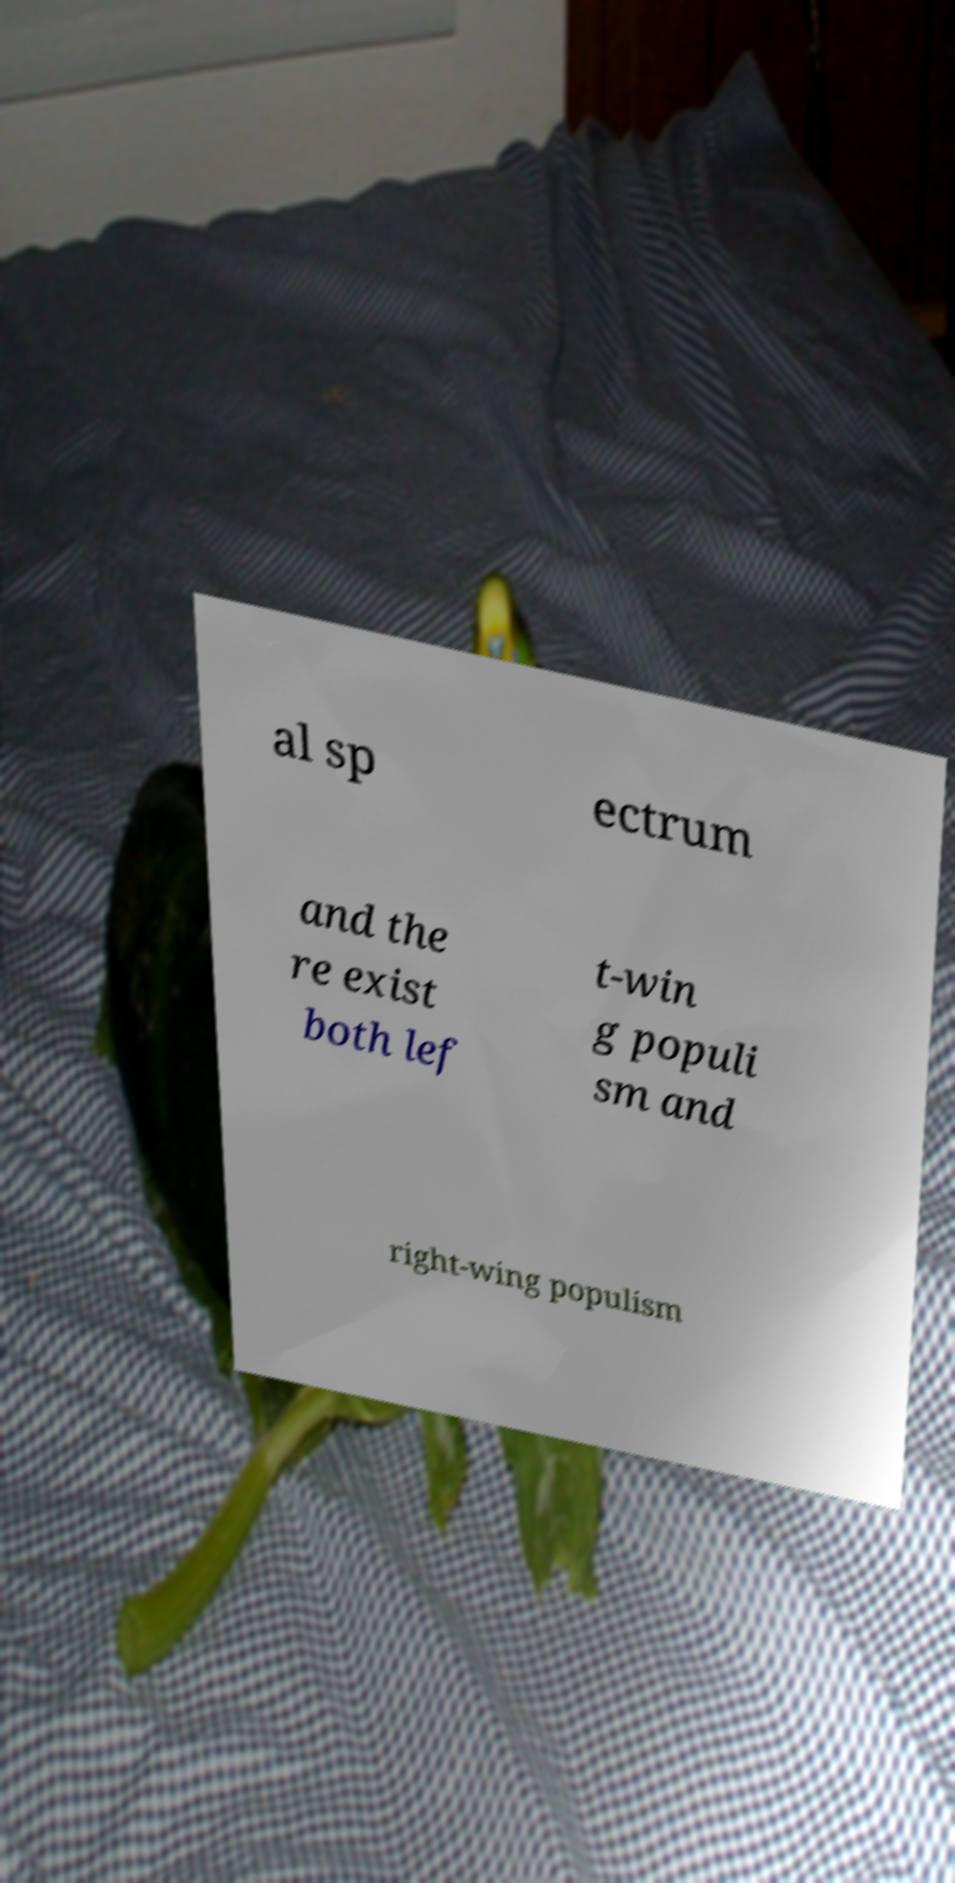Can you read and provide the text displayed in the image?This photo seems to have some interesting text. Can you extract and type it out for me? al sp ectrum and the re exist both lef t-win g populi sm and right-wing populism 